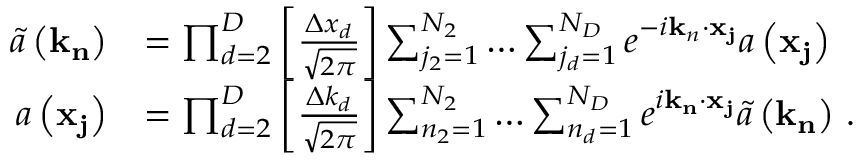Convert formula to latex. <formula><loc_0><loc_0><loc_500><loc_500>\begin{array} { r l } { \tilde { a } \left ( k _ { n } \right ) } & { = \prod _ { d = 2 } ^ { D } \left [ \frac { \Delta x _ { d } } { \sqrt { 2 \pi } } \right ] \sum _ { j _ { 2 } = 1 } ^ { N _ { 2 } } \dots \sum _ { j _ { d } = 1 } ^ { N _ { D } } e ^ { - i k _ { n } \cdot x _ { j } } a \left ( x _ { j } \right ) \, } \\ { a \left ( x _ { j } \right ) } & { = \prod _ { d = 2 } ^ { D } \left [ \frac { \Delta k _ { d } } { \sqrt { 2 \pi } } \right ] \sum _ { n _ { 2 } = 1 } ^ { N _ { 2 } } \dots \sum _ { n _ { d } = 1 } ^ { N _ { D } } e ^ { i k _ { n } \cdot x _ { j } } \tilde { a } \left ( k _ { n } \right ) \, . } \end{array}</formula> 